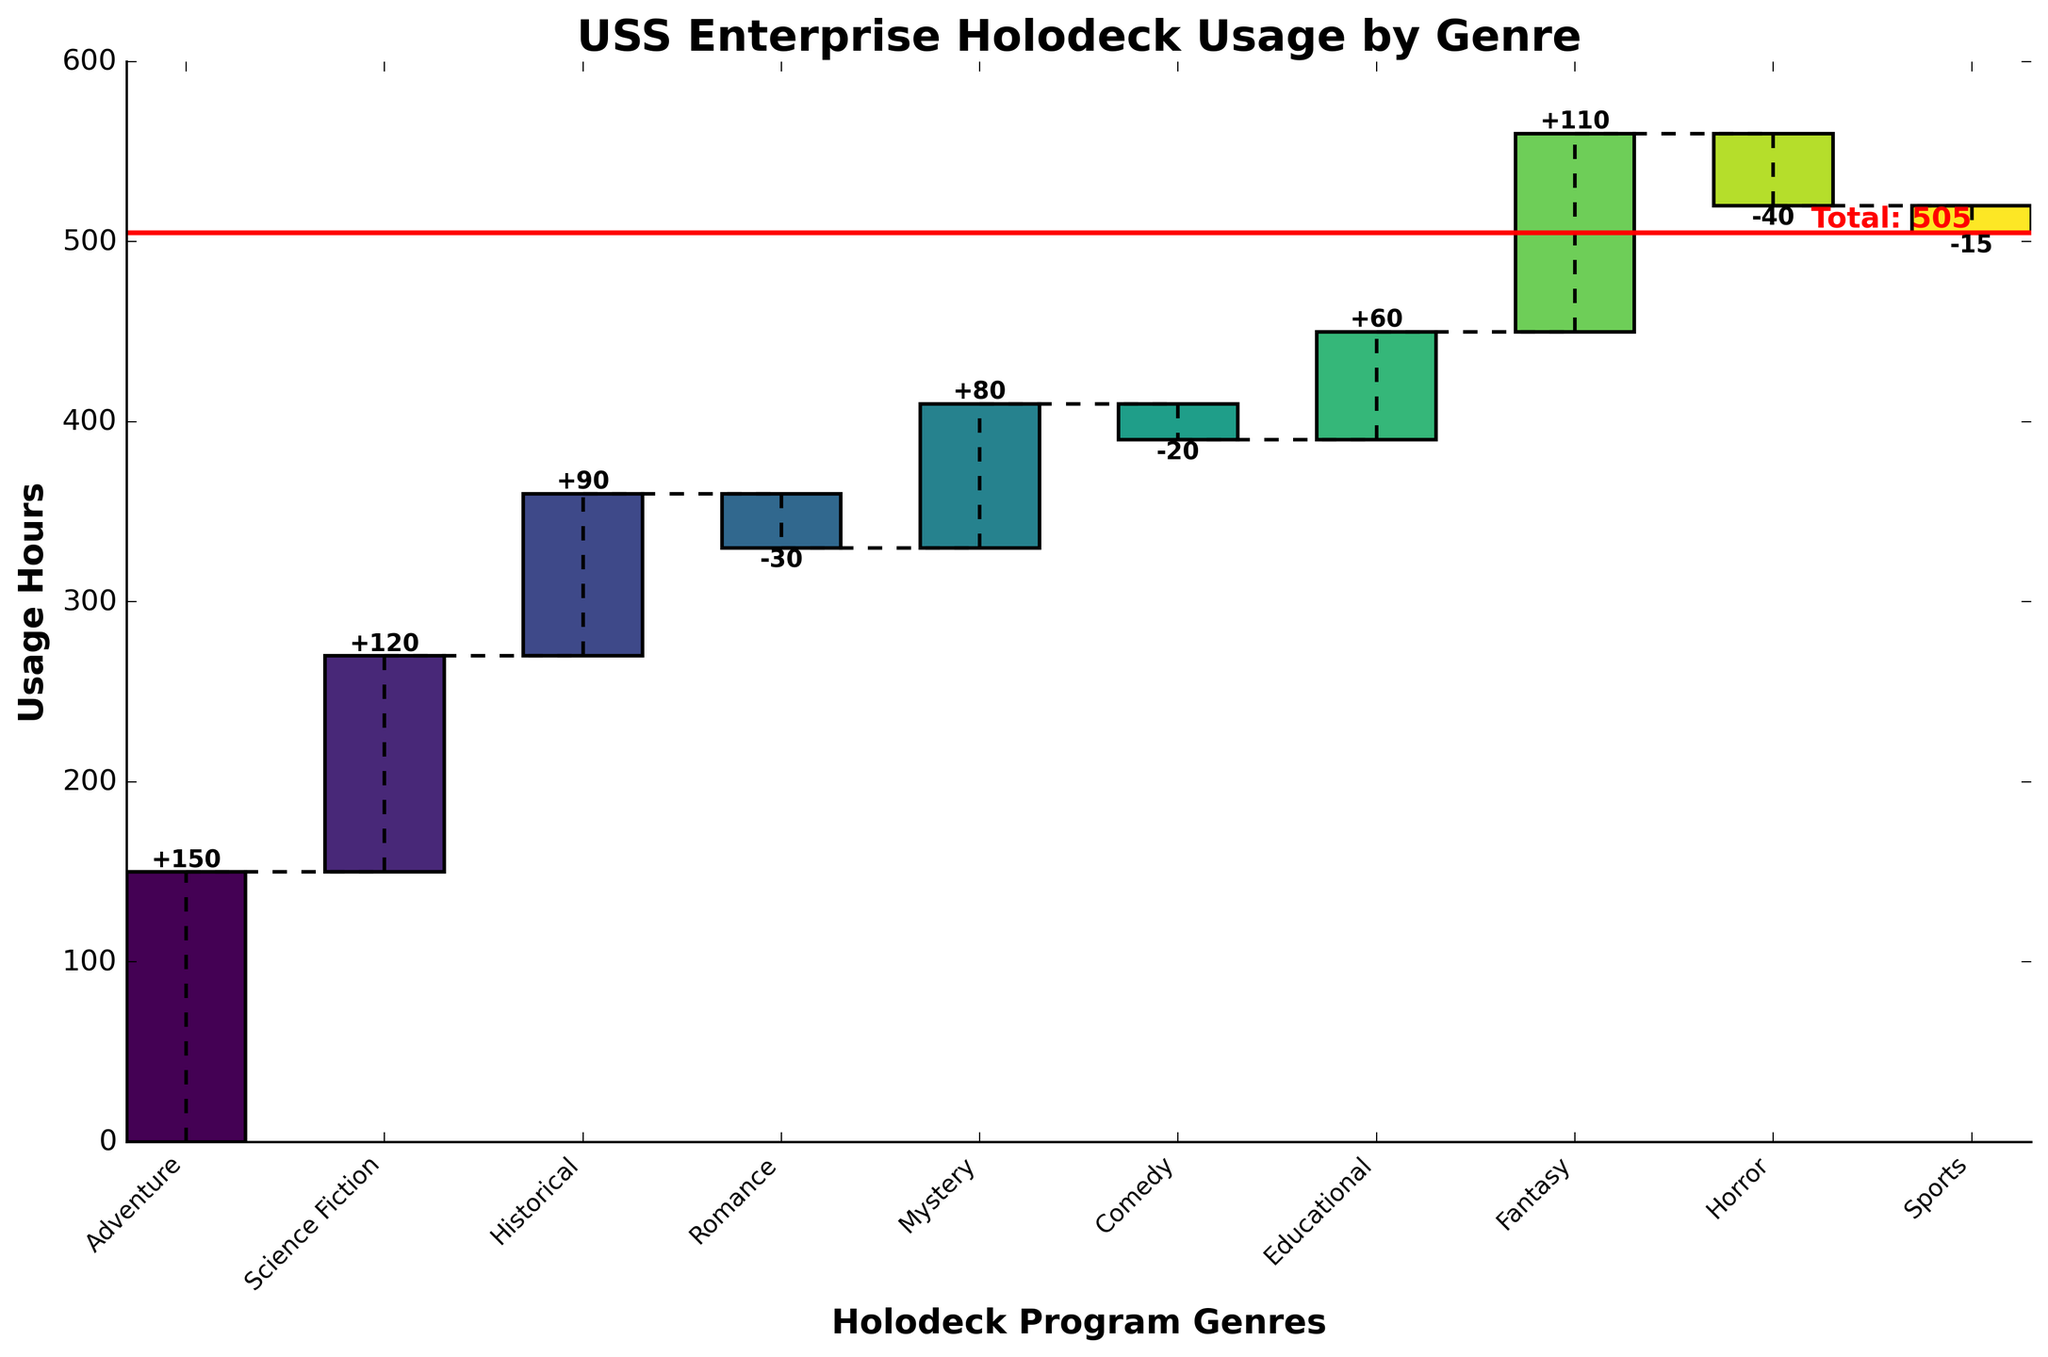What is the title of the chart? The title of the chart is written at the top center of the figure and reads 'USS Enterprise Holodeck Usage by Genre'.
Answer: USS Enterprise Holodeck Usage by Genre Which genre has the highest usage hours? To find the genre with the highest usage hours, look at the highest bar in the chart. The genre with the highest value in the positive bar is Adventure, which is 150 hours.
Answer: Adventure What is the total usage hours for all genres combined? The total usage hours is indicated by the red horizontal line and the label next to it on the right side of the figure, which is 505 hours.
Answer: 505 Which genre has the lowest usage hours significantly below zero? The genres with negative usage hours are depicted as bars extending downwards. The genre with the lowest value is Horror with -40 hours.
Answer: Horror How is the cumulative sum depicted in the chart? The chart uses connecting dashed lines to show the cumulative sum for each genre at the top of the bars, following the order of genres listed from left to right. The cumulative sum increases with positive values and decreases with negative values.
Answer: With dashed lines Between which two genres does the cumulative usage make a significant negative drop? To determine where a significant negative drop happens, look for a noticeable steep drop in the dashed lines. The largest significant drop happens between Historical and Romance. The cumulative value drops from 360 (Historical) to 330 (Romance), a decrease of -30 hours.
Answer: Historical and Romance What genres have negative usage hours? The genres with negative usage hours are represented by bars below the x-axis. These are Romance (-30), Comedy (-20), Horror (-40), and Sports (-15).
Answer: Romance, Comedy, Horror, Sports How does the chart show a logical sequence similar to how Captain Jean-Luc Picard strategically plans missions? The chart organizes the data logically, aligning it in a sequence of genres, and connects these with dashed lines to show the chain of cumulative usage hours, much like how Picard would consider each step during a mission to ensure the best outcome.
Answer: Logical sequence with cumulative steps What is the difference in usage hours between Fantasy and Horror? Fantasy shows a usage of 110 hours whereas Horror shows a usage of -40 hours. To find the difference: 110 - (-40) = 110 + 40 = 150 hours.
Answer: 150 hours Which two genres have the closest usage hours in value? Look for bars that are similar in length. The genres with usage hours closest in value are Fantasy (110) and Science Fiction (120), with a difference of 10 hours.
Answer: Fantasy and Science Fiction 